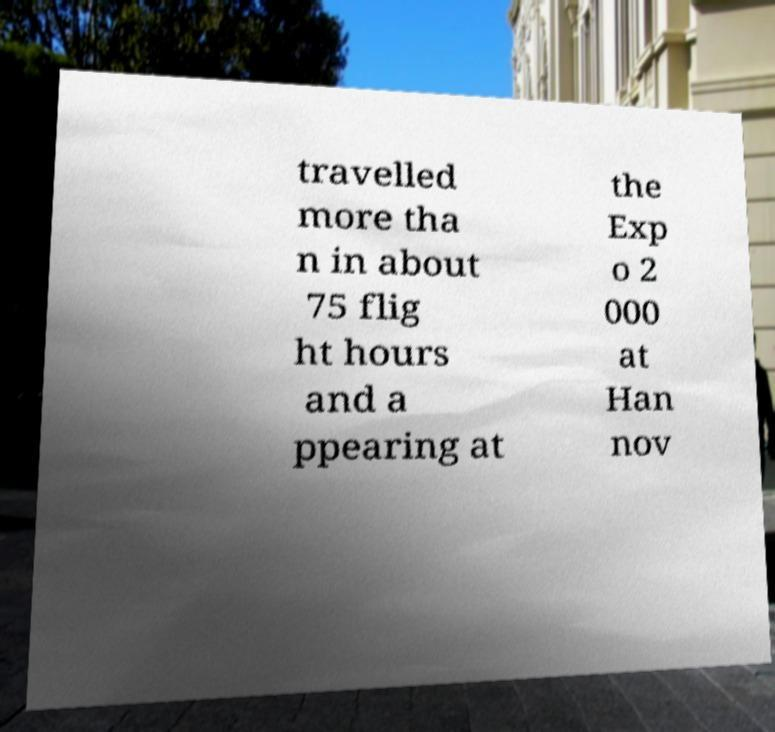Can you accurately transcribe the text from the provided image for me? travelled more tha n in about 75 flig ht hours and a ppearing at the Exp o 2 000 at Han nov 